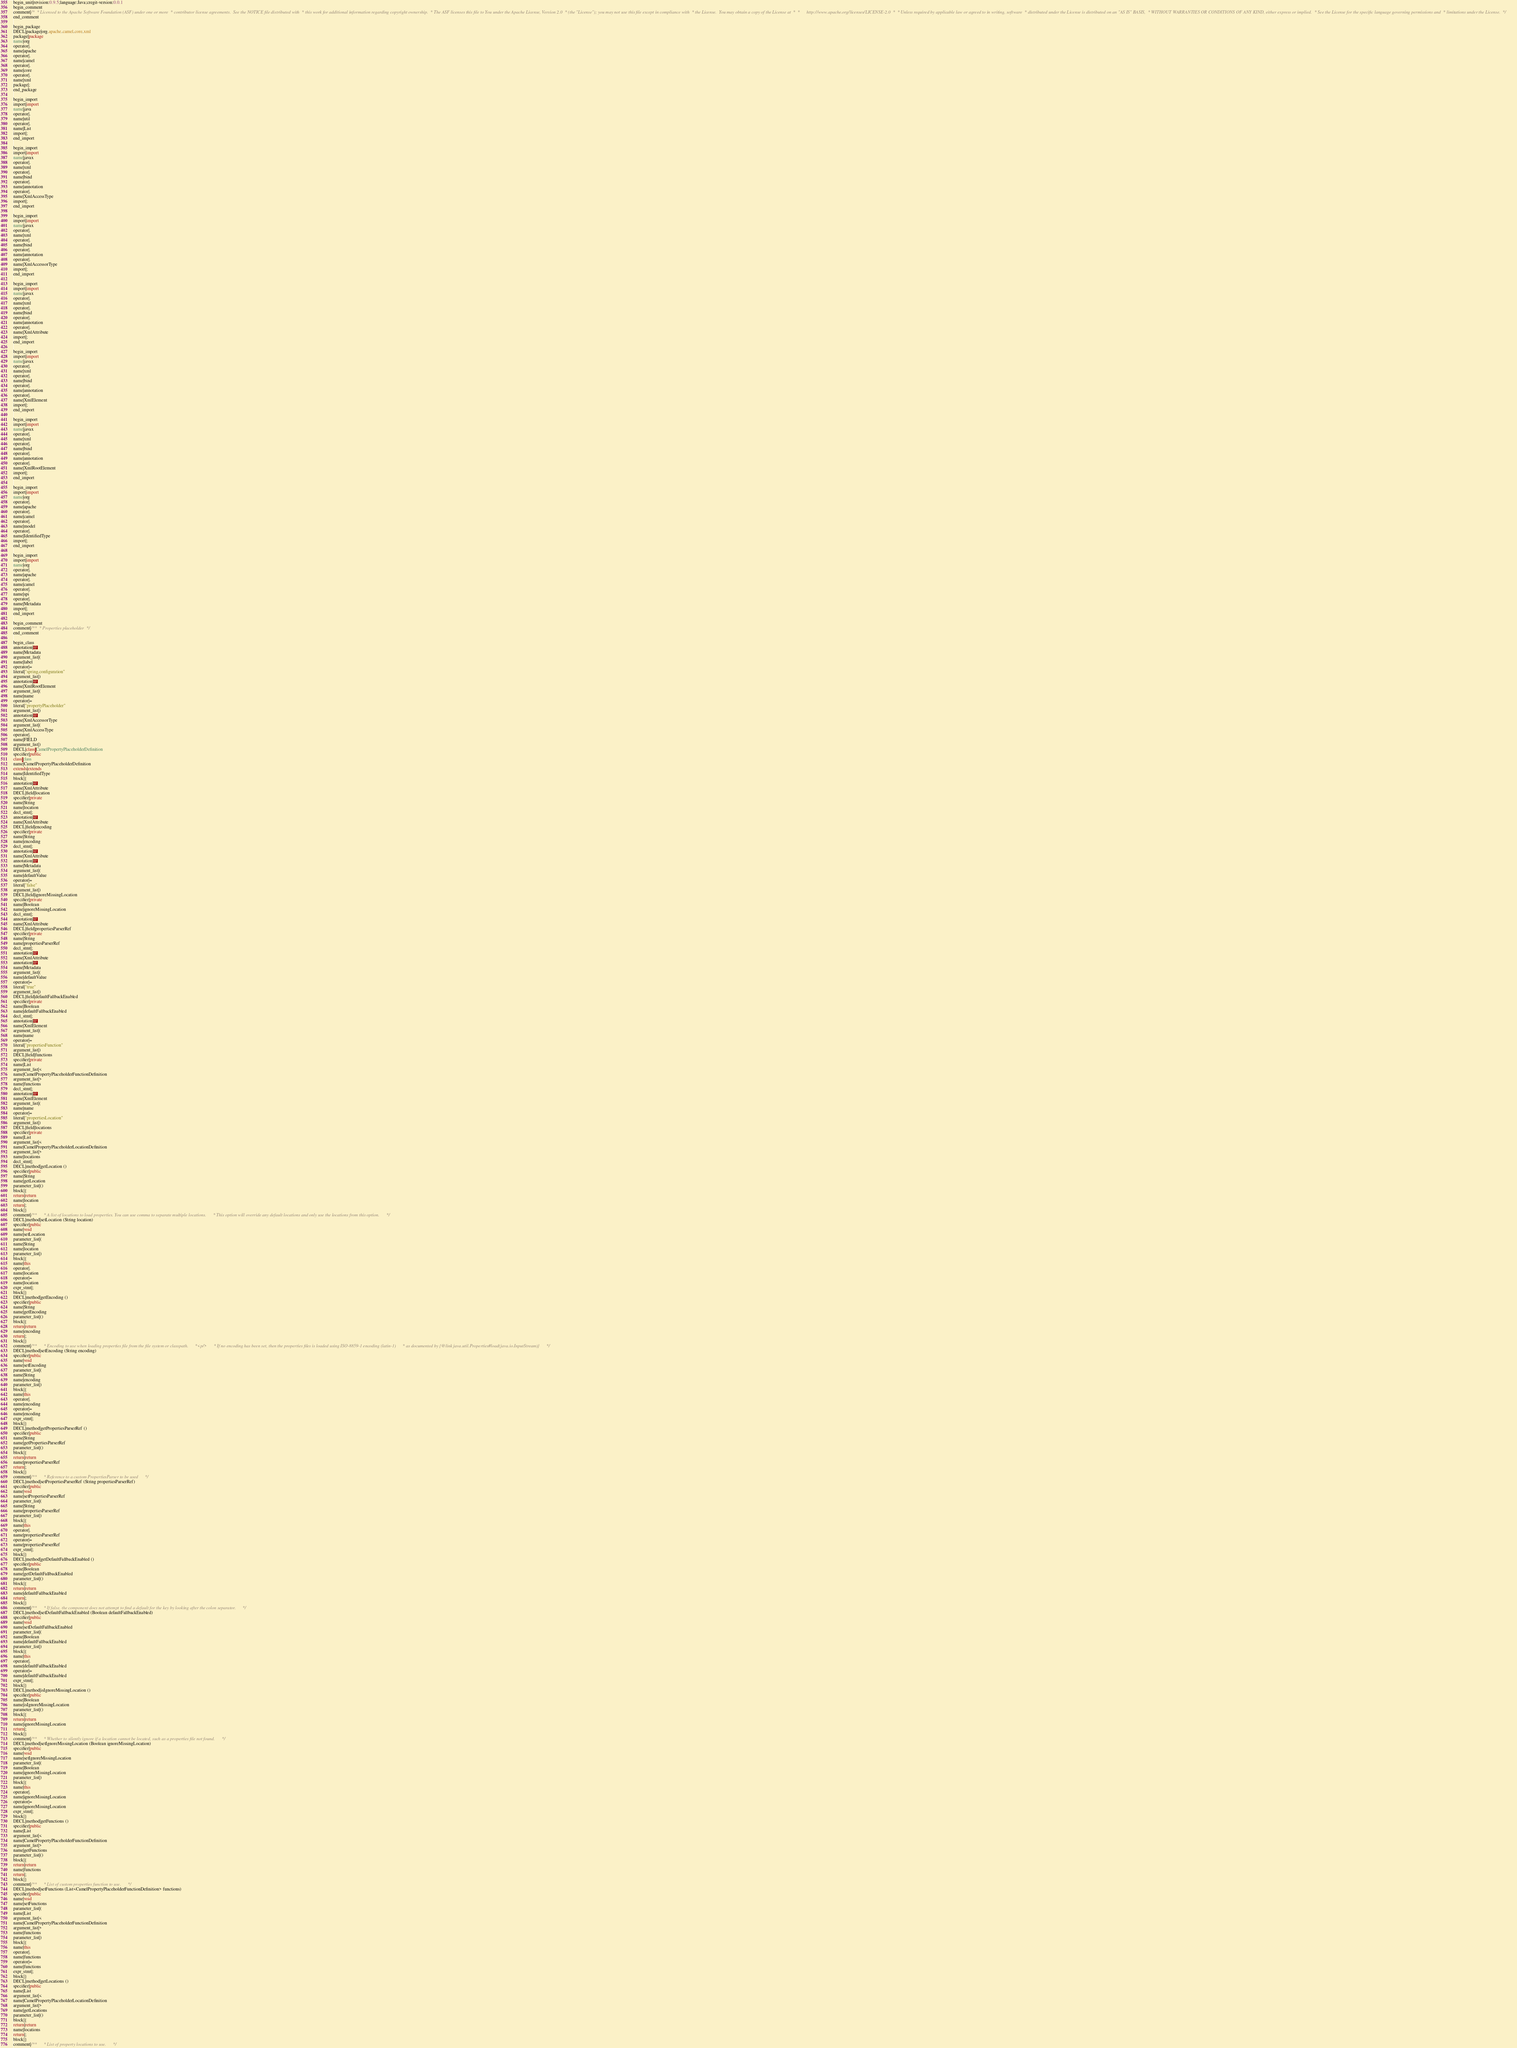Convert code to text. <code><loc_0><loc_0><loc_500><loc_500><_Java_>begin_unit|revision:0.9.5;language:Java;cregit-version:0.0.1
begin_comment
comment|/*  * Licensed to the Apache Software Foundation (ASF) under one or more  * contributor license agreements.  See the NOTICE file distributed with  * this work for additional information regarding copyright ownership.  * The ASF licenses this file to You under the Apache License, Version 2.0  * (the "License"); you may not use this file except in compliance with  * the License.  You may obtain a copy of the License at  *  *      http://www.apache.org/licenses/LICENSE-2.0  *  * Unless required by applicable law or agreed to in writing, software  * distributed under the License is distributed on an "AS IS" BASIS,  * WITHOUT WARRANTIES OR CONDITIONS OF ANY KIND, either express or implied.  * See the License for the specific language governing permissions and  * limitations under the License.  */
end_comment

begin_package
DECL|package|org.apache.camel.core.xml
package|package
name|org
operator|.
name|apache
operator|.
name|camel
operator|.
name|core
operator|.
name|xml
package|;
end_package

begin_import
import|import
name|java
operator|.
name|util
operator|.
name|List
import|;
end_import

begin_import
import|import
name|javax
operator|.
name|xml
operator|.
name|bind
operator|.
name|annotation
operator|.
name|XmlAccessType
import|;
end_import

begin_import
import|import
name|javax
operator|.
name|xml
operator|.
name|bind
operator|.
name|annotation
operator|.
name|XmlAccessorType
import|;
end_import

begin_import
import|import
name|javax
operator|.
name|xml
operator|.
name|bind
operator|.
name|annotation
operator|.
name|XmlAttribute
import|;
end_import

begin_import
import|import
name|javax
operator|.
name|xml
operator|.
name|bind
operator|.
name|annotation
operator|.
name|XmlElement
import|;
end_import

begin_import
import|import
name|javax
operator|.
name|xml
operator|.
name|bind
operator|.
name|annotation
operator|.
name|XmlRootElement
import|;
end_import

begin_import
import|import
name|org
operator|.
name|apache
operator|.
name|camel
operator|.
name|model
operator|.
name|IdentifiedType
import|;
end_import

begin_import
import|import
name|org
operator|.
name|apache
operator|.
name|camel
operator|.
name|spi
operator|.
name|Metadata
import|;
end_import

begin_comment
comment|/**  * Properties placeholder  */
end_comment

begin_class
annotation|@
name|Metadata
argument_list|(
name|label
operator|=
literal|"spring,configuration"
argument_list|)
annotation|@
name|XmlRootElement
argument_list|(
name|name
operator|=
literal|"propertyPlaceholder"
argument_list|)
annotation|@
name|XmlAccessorType
argument_list|(
name|XmlAccessType
operator|.
name|FIELD
argument_list|)
DECL|class|CamelPropertyPlaceholderDefinition
specifier|public
class|class
name|CamelPropertyPlaceholderDefinition
extends|extends
name|IdentifiedType
block|{
annotation|@
name|XmlAttribute
DECL|field|location
specifier|private
name|String
name|location
decl_stmt|;
annotation|@
name|XmlAttribute
DECL|field|encoding
specifier|private
name|String
name|encoding
decl_stmt|;
annotation|@
name|XmlAttribute
annotation|@
name|Metadata
argument_list|(
name|defaultValue
operator|=
literal|"false"
argument_list|)
DECL|field|ignoreMissingLocation
specifier|private
name|Boolean
name|ignoreMissingLocation
decl_stmt|;
annotation|@
name|XmlAttribute
DECL|field|propertiesParserRef
specifier|private
name|String
name|propertiesParserRef
decl_stmt|;
annotation|@
name|XmlAttribute
annotation|@
name|Metadata
argument_list|(
name|defaultValue
operator|=
literal|"true"
argument_list|)
DECL|field|defaultFallbackEnabled
specifier|private
name|Boolean
name|defaultFallbackEnabled
decl_stmt|;
annotation|@
name|XmlElement
argument_list|(
name|name
operator|=
literal|"propertiesFunction"
argument_list|)
DECL|field|functions
specifier|private
name|List
argument_list|<
name|CamelPropertyPlaceholderFunctionDefinition
argument_list|>
name|functions
decl_stmt|;
annotation|@
name|XmlElement
argument_list|(
name|name
operator|=
literal|"propertiesLocation"
argument_list|)
DECL|field|locations
specifier|private
name|List
argument_list|<
name|CamelPropertyPlaceholderLocationDefinition
argument_list|>
name|locations
decl_stmt|;
DECL|method|getLocation ()
specifier|public
name|String
name|getLocation
parameter_list|()
block|{
return|return
name|location
return|;
block|}
comment|/**      * A list of locations to load properties. You can use comma to separate multiple locations.      * This option will override any default locations and only use the locations from this option.      */
DECL|method|setLocation (String location)
specifier|public
name|void
name|setLocation
parameter_list|(
name|String
name|location
parameter_list|)
block|{
name|this
operator|.
name|location
operator|=
name|location
expr_stmt|;
block|}
DECL|method|getEncoding ()
specifier|public
name|String
name|getEncoding
parameter_list|()
block|{
return|return
name|encoding
return|;
block|}
comment|/**      * Encoding to use when loading properties file from the file system or classpath.      *<p/>      * If no encoding has been set, then the properties files is loaded using ISO-8859-1 encoding (latin-1)      * as documented by {@link java.util.Properties#load(java.io.InputStream)}      */
DECL|method|setEncoding (String encoding)
specifier|public
name|void
name|setEncoding
parameter_list|(
name|String
name|encoding
parameter_list|)
block|{
name|this
operator|.
name|encoding
operator|=
name|encoding
expr_stmt|;
block|}
DECL|method|getPropertiesParserRef ()
specifier|public
name|String
name|getPropertiesParserRef
parameter_list|()
block|{
return|return
name|propertiesParserRef
return|;
block|}
comment|/**      * Reference to a custom PropertiesParser to be used      */
DECL|method|setPropertiesParserRef (String propertiesParserRef)
specifier|public
name|void
name|setPropertiesParserRef
parameter_list|(
name|String
name|propertiesParserRef
parameter_list|)
block|{
name|this
operator|.
name|propertiesParserRef
operator|=
name|propertiesParserRef
expr_stmt|;
block|}
DECL|method|getDefaultFallbackEnabled ()
specifier|public
name|Boolean
name|getDefaultFallbackEnabled
parameter_list|()
block|{
return|return
name|defaultFallbackEnabled
return|;
block|}
comment|/**      * If false, the component does not attempt to find a default for the key by looking after the colon separator.      */
DECL|method|setDefaultFallbackEnabled (Boolean defaultFallbackEnabled)
specifier|public
name|void
name|setDefaultFallbackEnabled
parameter_list|(
name|Boolean
name|defaultFallbackEnabled
parameter_list|)
block|{
name|this
operator|.
name|defaultFallbackEnabled
operator|=
name|defaultFallbackEnabled
expr_stmt|;
block|}
DECL|method|isIgnoreMissingLocation ()
specifier|public
name|Boolean
name|isIgnoreMissingLocation
parameter_list|()
block|{
return|return
name|ignoreMissingLocation
return|;
block|}
comment|/**      * Whether to silently ignore if a location cannot be located, such as a properties file not found.      */
DECL|method|setIgnoreMissingLocation (Boolean ignoreMissingLocation)
specifier|public
name|void
name|setIgnoreMissingLocation
parameter_list|(
name|Boolean
name|ignoreMissingLocation
parameter_list|)
block|{
name|this
operator|.
name|ignoreMissingLocation
operator|=
name|ignoreMissingLocation
expr_stmt|;
block|}
DECL|method|getFunctions ()
specifier|public
name|List
argument_list|<
name|CamelPropertyPlaceholderFunctionDefinition
argument_list|>
name|getFunctions
parameter_list|()
block|{
return|return
name|functions
return|;
block|}
comment|/**      * List of custom properties function to use.      */
DECL|method|setFunctions (List<CamelPropertyPlaceholderFunctionDefinition> functions)
specifier|public
name|void
name|setFunctions
parameter_list|(
name|List
argument_list|<
name|CamelPropertyPlaceholderFunctionDefinition
argument_list|>
name|functions
parameter_list|)
block|{
name|this
operator|.
name|functions
operator|=
name|functions
expr_stmt|;
block|}
DECL|method|getLocations ()
specifier|public
name|List
argument_list|<
name|CamelPropertyPlaceholderLocationDefinition
argument_list|>
name|getLocations
parameter_list|()
block|{
return|return
name|locations
return|;
block|}
comment|/**      * List of property locations to use.      */</code> 